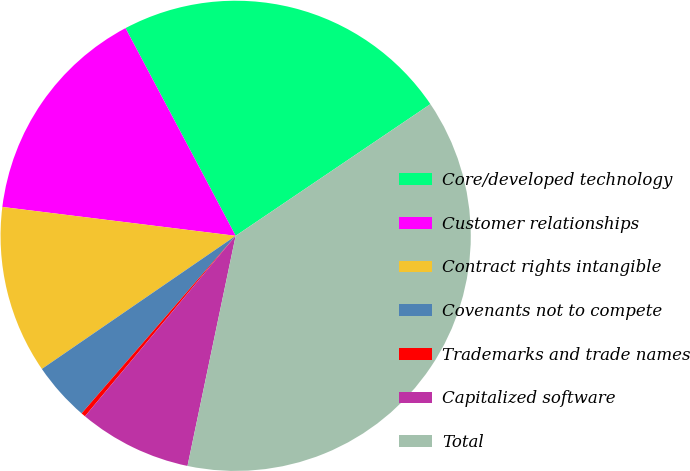Convert chart to OTSL. <chart><loc_0><loc_0><loc_500><loc_500><pie_chart><fcel>Core/developed technology<fcel>Customer relationships<fcel>Contract rights intangible<fcel>Covenants not to compete<fcel>Trademarks and trade names<fcel>Capitalized software<fcel>Total<nl><fcel>23.3%<fcel>15.28%<fcel>11.54%<fcel>4.05%<fcel>0.3%<fcel>7.79%<fcel>37.75%<nl></chart> 